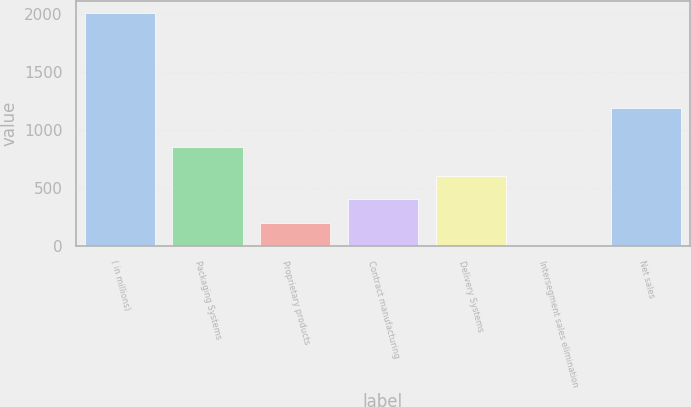<chart> <loc_0><loc_0><loc_500><loc_500><bar_chart><fcel>( in millions)<fcel>Packaging Systems<fcel>Proprietary products<fcel>Contract manufacturing<fcel>Delivery Systems<fcel>Intersegment sales elimination<fcel>Net sales<nl><fcel>2011<fcel>857.4<fcel>202.72<fcel>403.64<fcel>604.56<fcel>1.8<fcel>1192.3<nl></chart> 